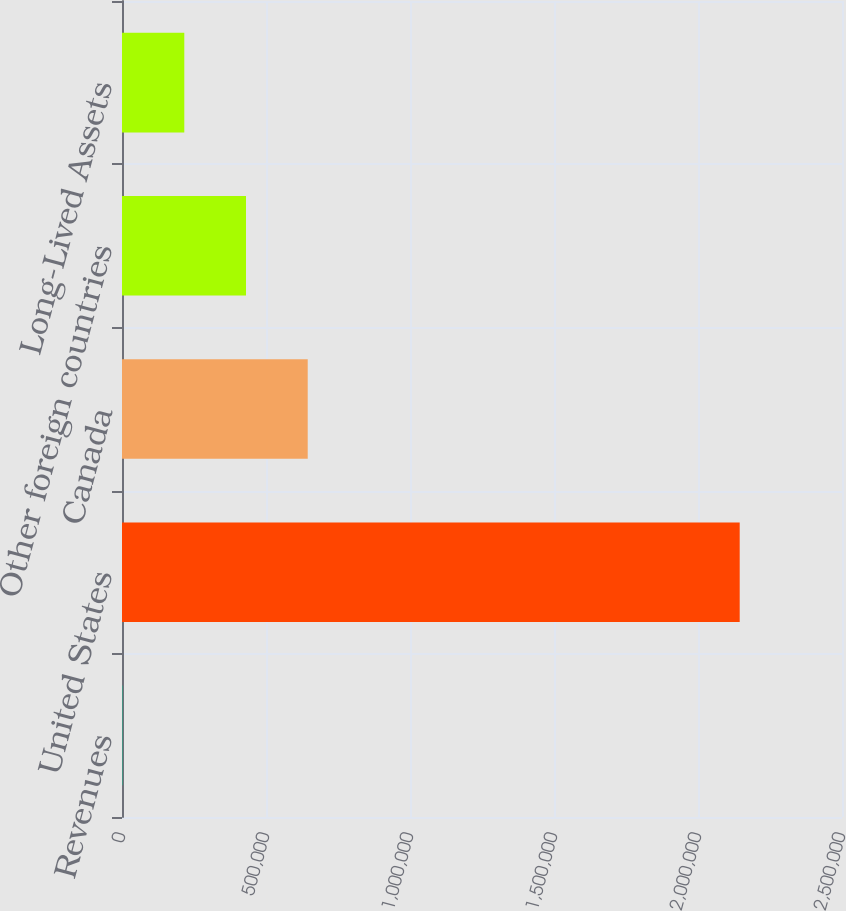<chart> <loc_0><loc_0><loc_500><loc_500><bar_chart><fcel>Revenues<fcel>United States<fcel>Canada<fcel>Other foreign countries<fcel>Long-Lived Assets<nl><fcel>2008<fcel>2.14481e+06<fcel>644848<fcel>430568<fcel>216288<nl></chart> 